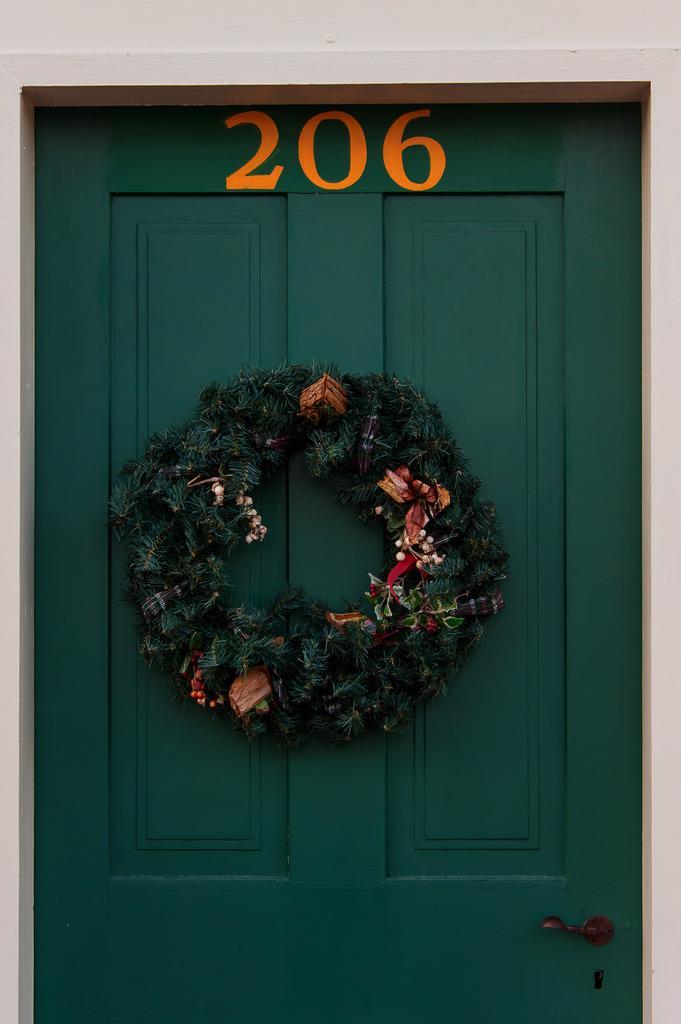Please provide a concise description of this image. In this image I can see there is a garland that is attached to the door. This door is in green color and there is the number at the top 206 in orange color. 